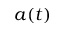Convert formula to latex. <formula><loc_0><loc_0><loc_500><loc_500>a ( t )</formula> 